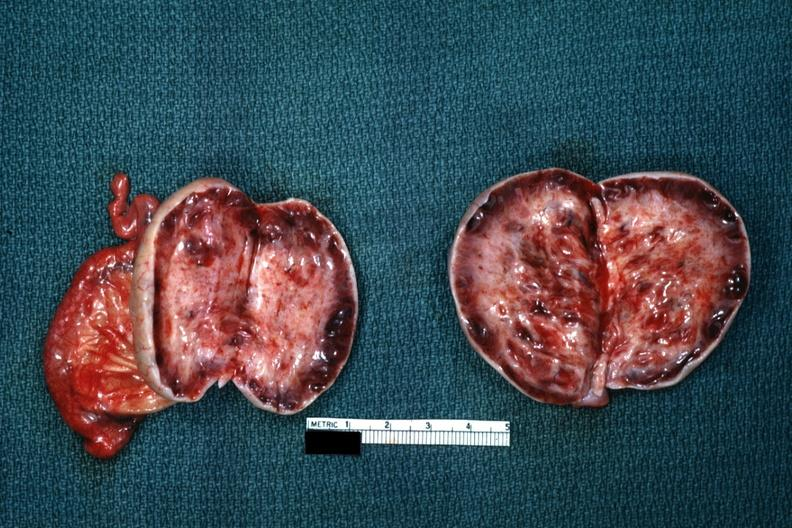what is present?
Answer the question using a single word or phrase. Female reproductive 